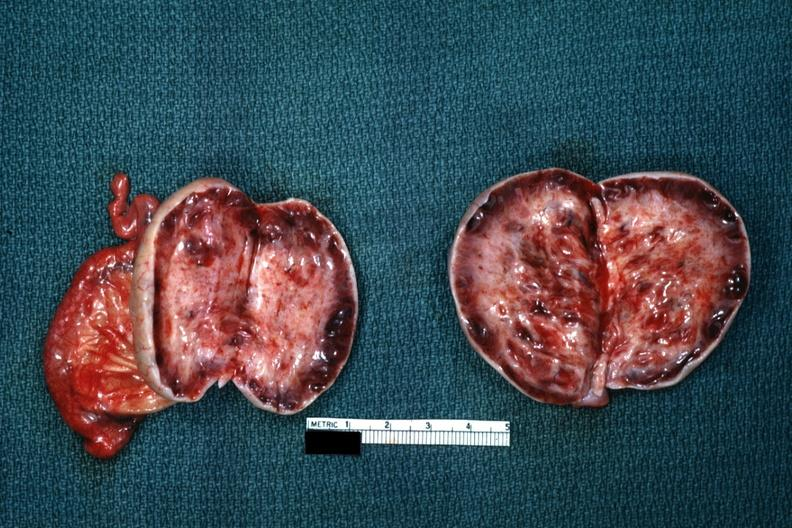what is present?
Answer the question using a single word or phrase. Female reproductive 